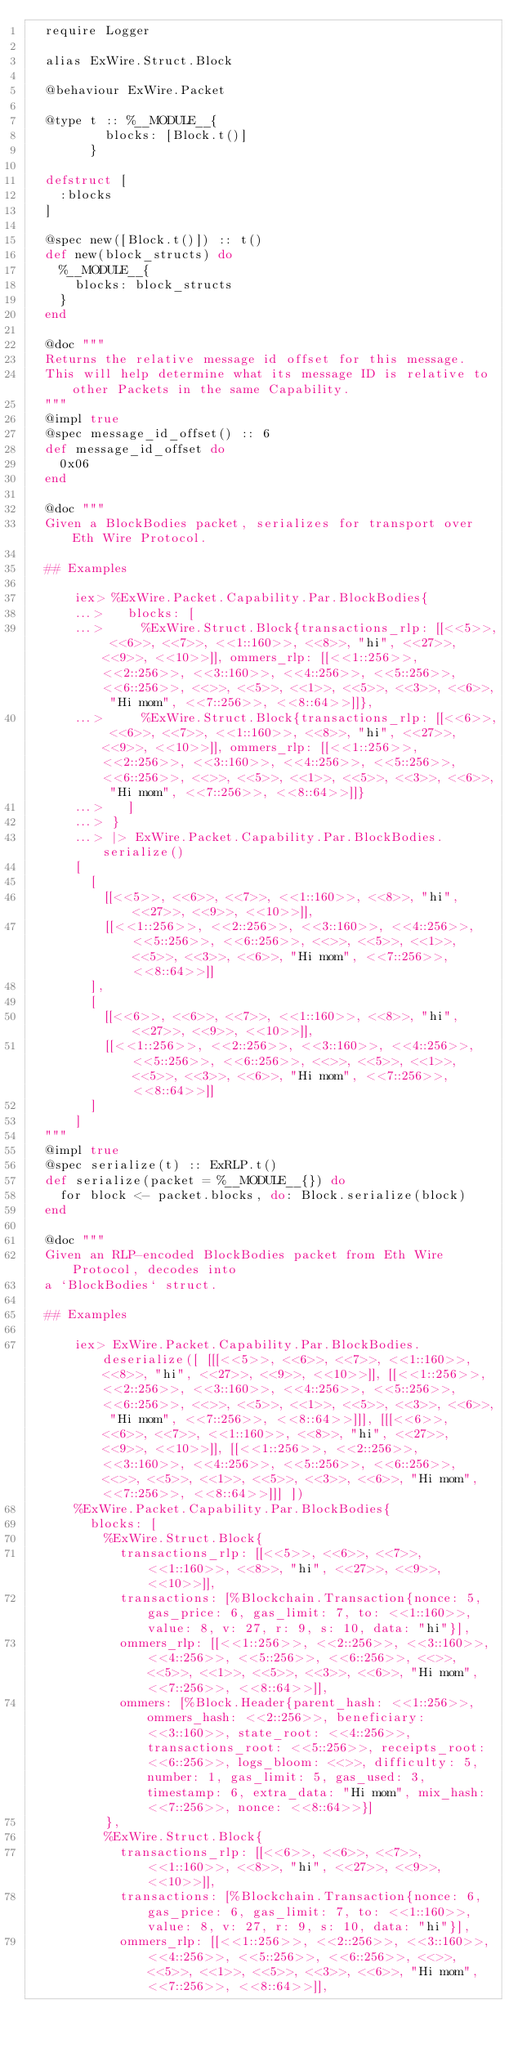Convert code to text. <code><loc_0><loc_0><loc_500><loc_500><_Elixir_>  require Logger

  alias ExWire.Struct.Block

  @behaviour ExWire.Packet

  @type t :: %__MODULE__{
          blocks: [Block.t()]
        }

  defstruct [
    :blocks
  ]

  @spec new([Block.t()]) :: t()
  def new(block_structs) do
    %__MODULE__{
      blocks: block_structs
    }
  end

  @doc """
  Returns the relative message id offset for this message.
  This will help determine what its message ID is relative to other Packets in the same Capability.
  """
  @impl true
  @spec message_id_offset() :: 6
  def message_id_offset do
    0x06
  end

  @doc """
  Given a BlockBodies packet, serializes for transport over Eth Wire Protocol.

  ## Examples

      iex> %ExWire.Packet.Capability.Par.BlockBodies{
      ...>   blocks: [
      ...>     %ExWire.Struct.Block{transactions_rlp: [[<<5>>, <<6>>, <<7>>, <<1::160>>, <<8>>, "hi", <<27>>, <<9>>, <<10>>]], ommers_rlp: [[<<1::256>>, <<2::256>>, <<3::160>>, <<4::256>>, <<5::256>>, <<6::256>>, <<>>, <<5>>, <<1>>, <<5>>, <<3>>, <<6>>, "Hi mom", <<7::256>>, <<8::64>>]]},
      ...>     %ExWire.Struct.Block{transactions_rlp: [[<<6>>, <<6>>, <<7>>, <<1::160>>, <<8>>, "hi", <<27>>, <<9>>, <<10>>]], ommers_rlp: [[<<1::256>>, <<2::256>>, <<3::160>>, <<4::256>>, <<5::256>>, <<6::256>>, <<>>, <<5>>, <<1>>, <<5>>, <<3>>, <<6>>, "Hi mom", <<7::256>>, <<8::64>>]]}
      ...>   ]
      ...> }
      ...> |> ExWire.Packet.Capability.Par.BlockBodies.serialize()
      [
        [
          [[<<5>>, <<6>>, <<7>>, <<1::160>>, <<8>>, "hi", <<27>>, <<9>>, <<10>>]],
          [[<<1::256>>, <<2::256>>, <<3::160>>, <<4::256>>, <<5::256>>, <<6::256>>, <<>>, <<5>>, <<1>>, <<5>>, <<3>>, <<6>>, "Hi mom", <<7::256>>, <<8::64>>]]
        ],
        [
          [[<<6>>, <<6>>, <<7>>, <<1::160>>, <<8>>, "hi", <<27>>, <<9>>, <<10>>]],
          [[<<1::256>>, <<2::256>>, <<3::160>>, <<4::256>>, <<5::256>>, <<6::256>>, <<>>, <<5>>, <<1>>, <<5>>, <<3>>, <<6>>, "Hi mom", <<7::256>>, <<8::64>>]]
        ]
      ]
  """
  @impl true
  @spec serialize(t) :: ExRLP.t()
  def serialize(packet = %__MODULE__{}) do
    for block <- packet.blocks, do: Block.serialize(block)
  end

  @doc """
  Given an RLP-encoded BlockBodies packet from Eth Wire Protocol, decodes into
  a `BlockBodies` struct.

  ## Examples

      iex> ExWire.Packet.Capability.Par.BlockBodies.deserialize([ [[[<<5>>, <<6>>, <<7>>, <<1::160>>, <<8>>, "hi", <<27>>, <<9>>, <<10>>]], [[<<1::256>>, <<2::256>>, <<3::160>>, <<4::256>>, <<5::256>>, <<6::256>>, <<>>, <<5>>, <<1>>, <<5>>, <<3>>, <<6>>, "Hi mom", <<7::256>>, <<8::64>>]]], [[[<<6>>, <<6>>, <<7>>, <<1::160>>, <<8>>, "hi", <<27>>, <<9>>, <<10>>]], [[<<1::256>>, <<2::256>>, <<3::160>>, <<4::256>>, <<5::256>>, <<6::256>>, <<>>, <<5>>, <<1>>, <<5>>, <<3>>, <<6>>, "Hi mom", <<7::256>>, <<8::64>>]]] ])
      %ExWire.Packet.Capability.Par.BlockBodies{
        blocks: [
          %ExWire.Struct.Block{
            transactions_rlp: [[<<5>>, <<6>>, <<7>>, <<1::160>>, <<8>>, "hi", <<27>>, <<9>>, <<10>>]],
            transactions: [%Blockchain.Transaction{nonce: 5, gas_price: 6, gas_limit: 7, to: <<1::160>>, value: 8, v: 27, r: 9, s: 10, data: "hi"}],
            ommers_rlp: [[<<1::256>>, <<2::256>>, <<3::160>>, <<4::256>>, <<5::256>>, <<6::256>>, <<>>, <<5>>, <<1>>, <<5>>, <<3>>, <<6>>, "Hi mom", <<7::256>>, <<8::64>>]],
            ommers: [%Block.Header{parent_hash: <<1::256>>, ommers_hash: <<2::256>>, beneficiary: <<3::160>>, state_root: <<4::256>>, transactions_root: <<5::256>>, receipts_root: <<6::256>>, logs_bloom: <<>>, difficulty: 5, number: 1, gas_limit: 5, gas_used: 3, timestamp: 6, extra_data: "Hi mom", mix_hash: <<7::256>>, nonce: <<8::64>>}]
          },
          %ExWire.Struct.Block{
            transactions_rlp: [[<<6>>, <<6>>, <<7>>, <<1::160>>, <<8>>, "hi", <<27>>, <<9>>, <<10>>]],
            transactions: [%Blockchain.Transaction{nonce: 6, gas_price: 6, gas_limit: 7, to: <<1::160>>, value: 8, v: 27, r: 9, s: 10, data: "hi"}],
            ommers_rlp: [[<<1::256>>, <<2::256>>, <<3::160>>, <<4::256>>, <<5::256>>, <<6::256>>, <<>>, <<5>>, <<1>>, <<5>>, <<3>>, <<6>>, "Hi mom", <<7::256>>, <<8::64>>]],</code> 